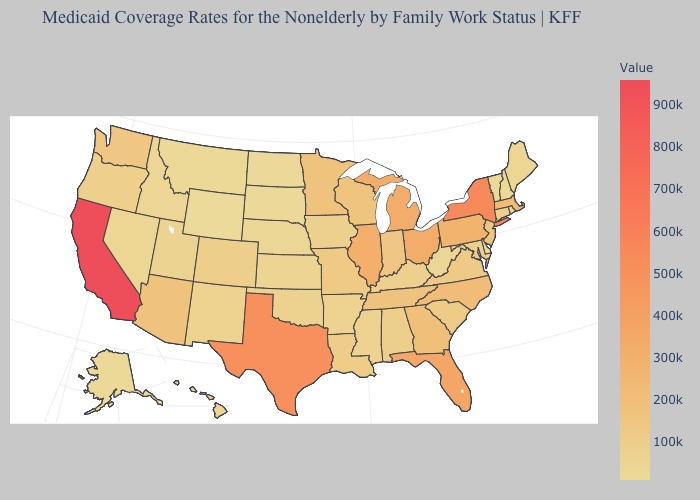Does the map have missing data?
Give a very brief answer. No. Which states hav the highest value in the South?
Keep it brief. Texas. Does the map have missing data?
Answer briefly. No. Is the legend a continuous bar?
Give a very brief answer. Yes. Among the states that border Ohio , which have the highest value?
Give a very brief answer. Michigan. Does Hawaii have a higher value than Tennessee?
Keep it brief. No. 